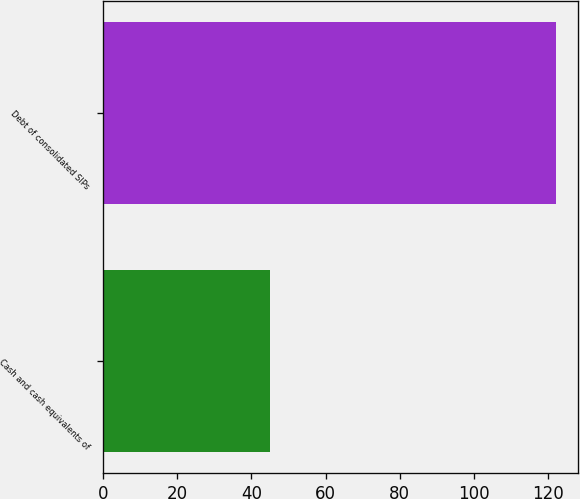Convert chart. <chart><loc_0><loc_0><loc_500><loc_500><bar_chart><fcel>Cash and cash equivalents of<fcel>Debt of consolidated SIPs<nl><fcel>44.9<fcel>122<nl></chart> 